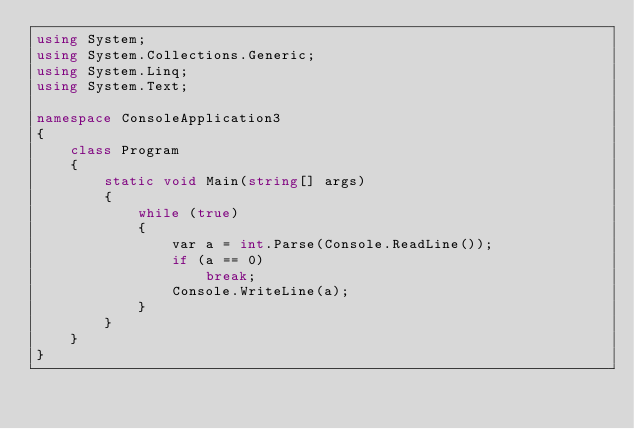Convert code to text. <code><loc_0><loc_0><loc_500><loc_500><_C#_>using System;
using System.Collections.Generic;
using System.Linq;
using System.Text;

namespace ConsoleApplication3
{
    class Program
    {
        static void Main(string[] args)
        {
            while (true)
            {
                var a = int.Parse(Console.ReadLine());
                if (a == 0)
                    break;
                Console.WriteLine(a);
            }
        }
    }
}</code> 